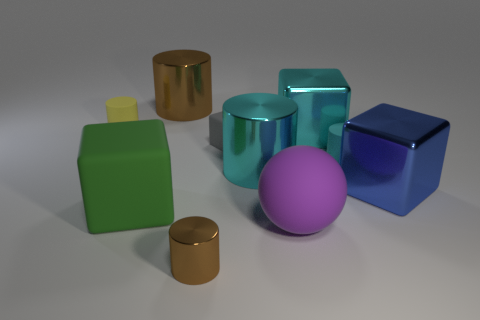Subtract all green cubes. Subtract all yellow cylinders. How many cubes are left? 3 Subtract all balls. How many objects are left? 9 Add 9 small gray blocks. How many small gray blocks are left? 10 Add 2 small rubber cylinders. How many small rubber cylinders exist? 4 Subtract 0 gray cylinders. How many objects are left? 10 Subtract all large red shiny cubes. Subtract all large matte spheres. How many objects are left? 9 